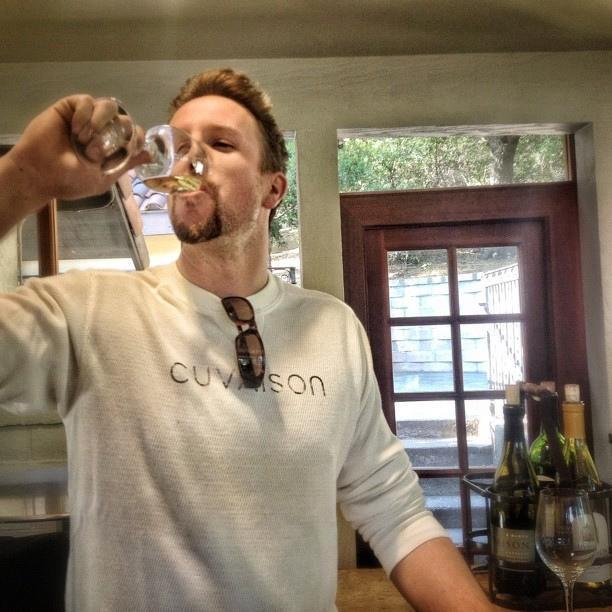How many wine glasses are in the photo?
Give a very brief answer. 2. How many bottles are in the photo?
Give a very brief answer. 3. 